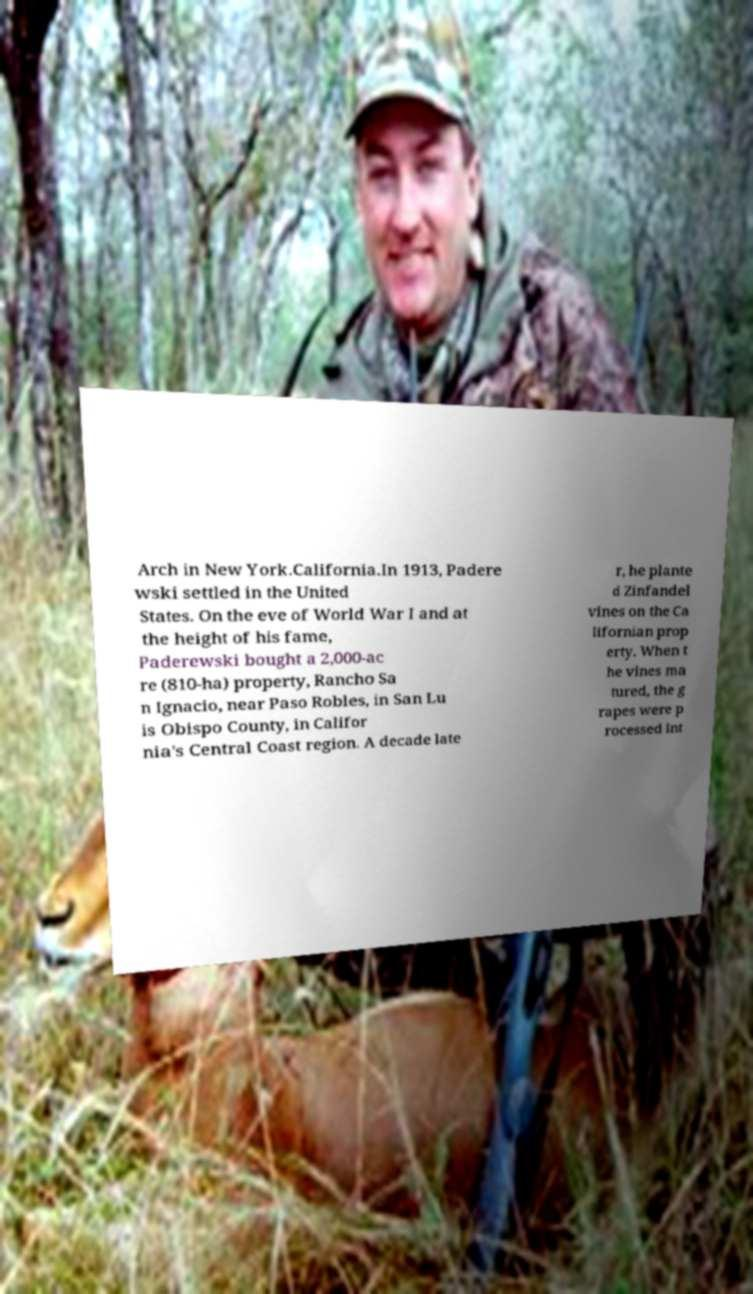For documentation purposes, I need the text within this image transcribed. Could you provide that? Arch in New York.California.In 1913, Padere wski settled in the United States. On the eve of World War I and at the height of his fame, Paderewski bought a 2,000-ac re (810-ha) property, Rancho Sa n Ignacio, near Paso Robles, in San Lu is Obispo County, in Califor nia's Central Coast region. A decade late r, he plante d Zinfandel vines on the Ca lifornian prop erty. When t he vines ma tured, the g rapes were p rocessed int 